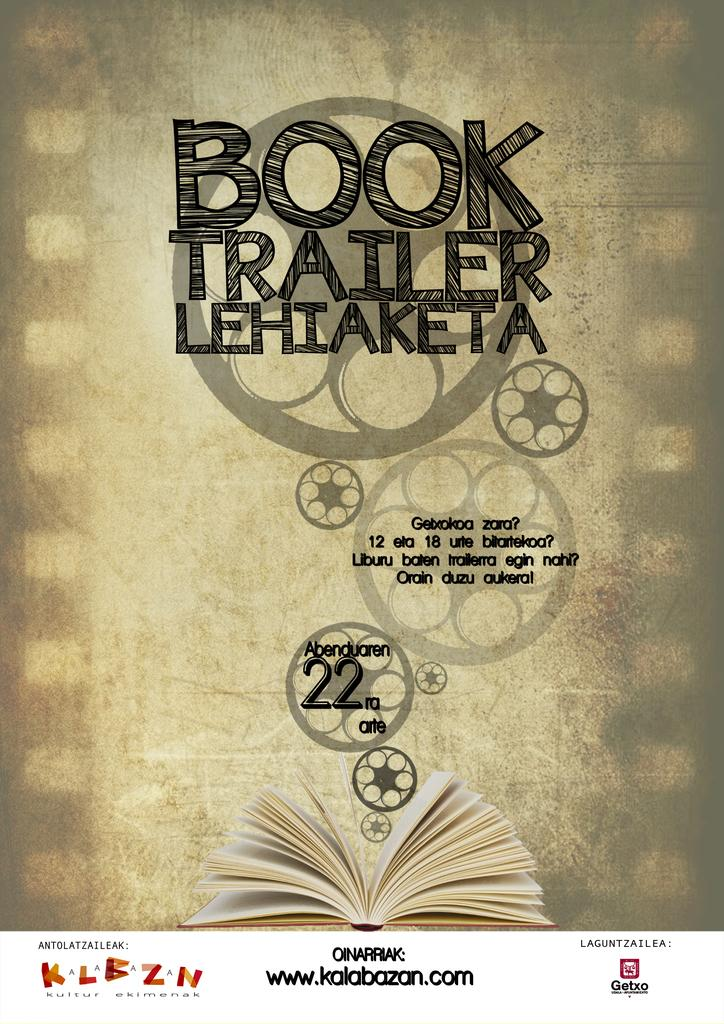Provide a one-sentence caption for the provided image. Promotion for how to make a Book Trailer, presented by kalabazan.com. 